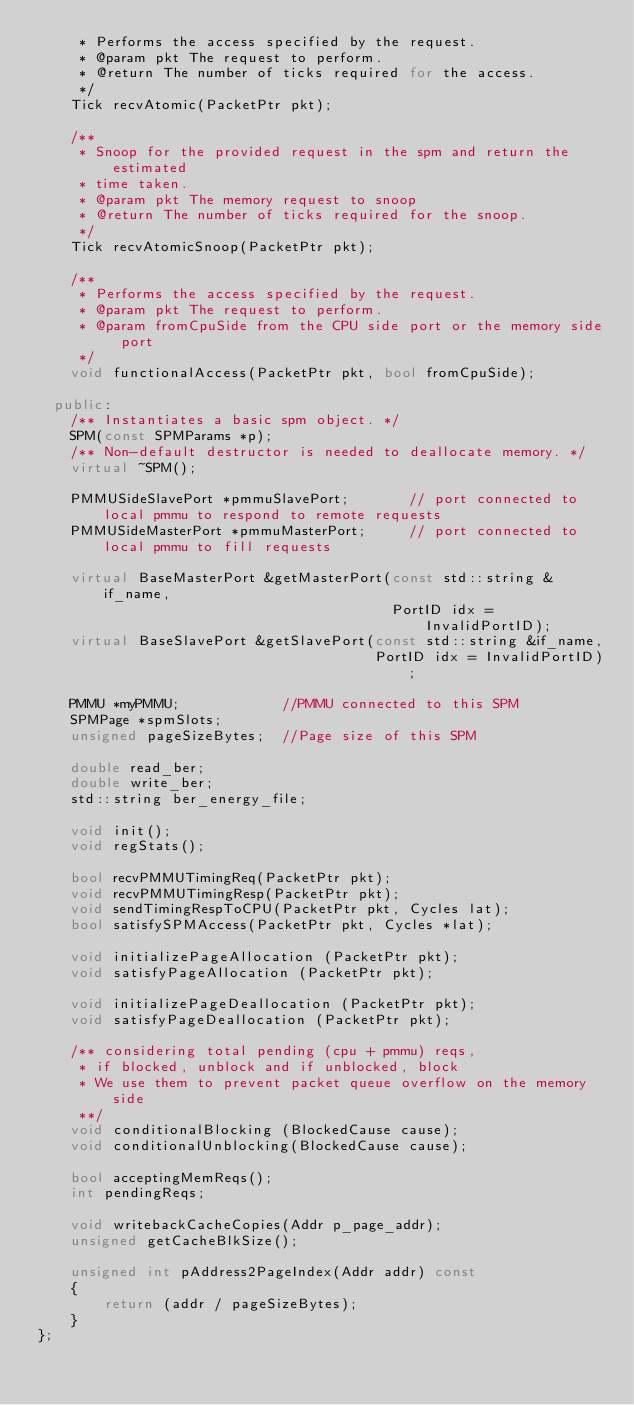Convert code to text. <code><loc_0><loc_0><loc_500><loc_500><_C++_>     * Performs the access specified by the request.
     * @param pkt The request to perform.
     * @return The number of ticks required for the access.
     */
    Tick recvAtomic(PacketPtr pkt);

    /**
     * Snoop for the provided request in the spm and return the estimated
     * time taken.
     * @param pkt The memory request to snoop
     * @return The number of ticks required for the snoop.
     */
    Tick recvAtomicSnoop(PacketPtr pkt);

    /**
     * Performs the access specified by the request.
     * @param pkt The request to perform.
     * @param fromCpuSide from the CPU side port or the memory side port
     */
    void functionalAccess(PacketPtr pkt, bool fromCpuSide);

  public:
    /** Instantiates a basic spm object. */
    SPM(const SPMParams *p);
    /** Non-default destructor is needed to deallocate memory. */
    virtual ~SPM();

    PMMUSideSlavePort *pmmuSlavePort;       // port connected to local pmmu to respond to remote requests
    PMMUSideMasterPort *pmmuMasterPort;     // port connected to local pmmu to fill requests

    virtual BaseMasterPort &getMasterPort(const std::string &if_name,
                                          PortID idx = InvalidPortID);
    virtual BaseSlavePort &getSlavePort(const std::string &if_name,
                                        PortID idx = InvalidPortID);

    PMMU *myPMMU;            //PMMU connected to this SPM
    SPMPage *spmSlots;
    unsigned pageSizeBytes;  //Page size of this SPM

    double read_ber;
    double write_ber;
    std::string ber_energy_file;

    void init();
    void regStats();

    bool recvPMMUTimingReq(PacketPtr pkt);
    void recvPMMUTimingResp(PacketPtr pkt);
    void sendTimingRespToCPU(PacketPtr pkt, Cycles lat);
    bool satisfySPMAccess(PacketPtr pkt, Cycles *lat);

    void initializePageAllocation (PacketPtr pkt);
    void satisfyPageAllocation (PacketPtr pkt);

    void initializePageDeallocation (PacketPtr pkt);
    void satisfyPageDeallocation (PacketPtr pkt);

    /** considering total pending (cpu + pmmu) reqs,
     * if blocked, unblock and if unblocked, block
     * We use them to prevent packet queue overflow on the memory side
     **/
    void conditionalBlocking (BlockedCause cause);
    void conditionalUnblocking(BlockedCause cause);

    bool acceptingMemReqs();
    int pendingReqs;

    void writebackCacheCopies(Addr p_page_addr);
    unsigned getCacheBlkSize();

    unsigned int pAddress2PageIndex(Addr addr) const
    {
        return (addr / pageSizeBytes);
    }
};</code> 